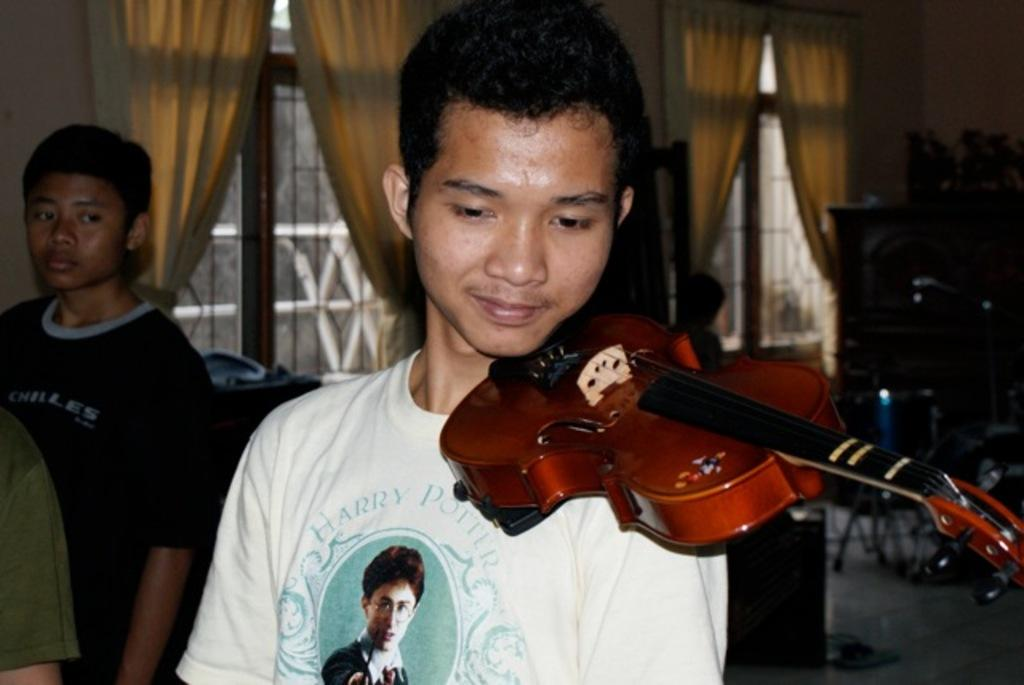What is the boy in the image holding? The boy is holding a violin. Can you describe the other boy in the image? There is another boy standing behind him. What can be seen in the background of the image? There are windows in the background. What type of window treatment is present in the image? There are curtains associated with the windows. What type of punishment is the boy receiving for playing the violin in the image? There is no indication of punishment in the image; the boy is simply holding a violin. Can you describe the volleyball game happening in the background of the image? There is no volleyball game present in the image; the background features windows and curtains. 